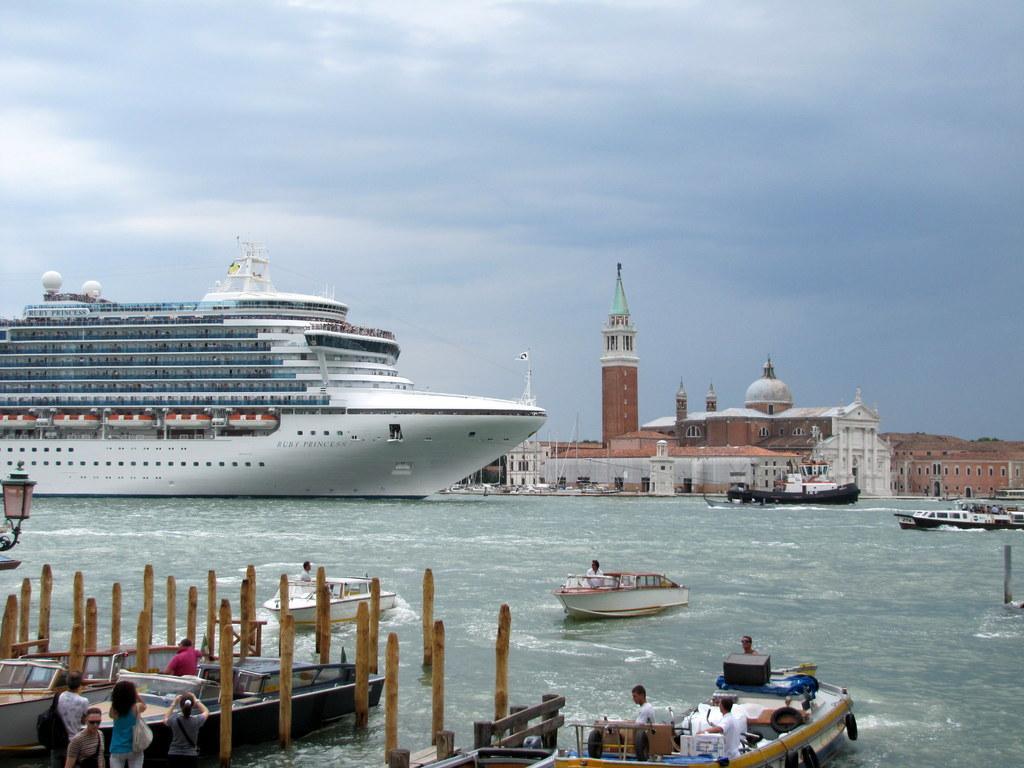How would you summarize this image in a sentence or two? In this picture we can see water at the bottom, there is a ship and some boats in the water, we can see some people standing at the left bottom, on the left side there is a light, in the background we can see buildings, there is the sky at the top of the picture. 